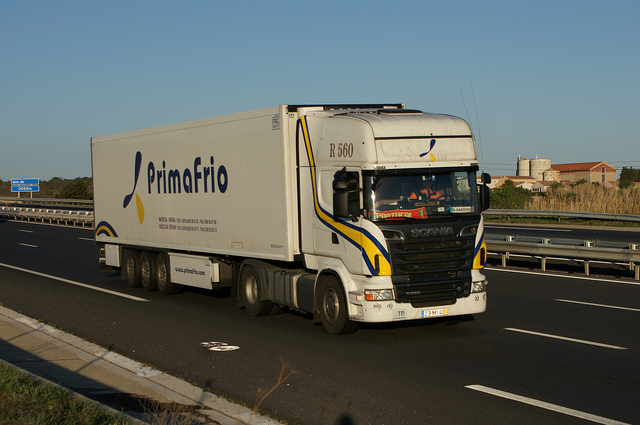Please identify all text content in this image. PrimaFrio R 560 